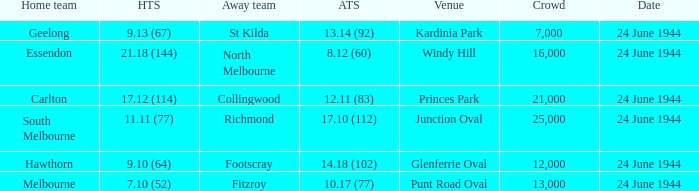When Essendon was the Home Team, what was the Away Team score? 8.12 (60). 